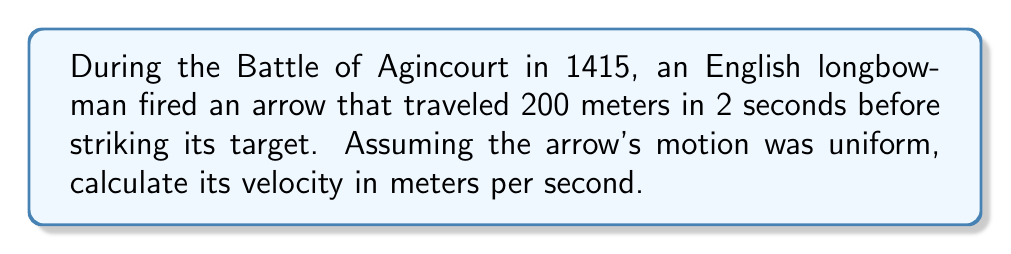Could you help me with this problem? To solve this problem, we'll use the concept of average velocity, which is defined as the displacement divided by the time taken. In this case, we have:

1. Distance traveled (displacement): $d = 200$ meters
2. Time taken: $t = 2$ seconds

The formula for average velocity is:

$$v = \frac{d}{t}$$

Where:
$v$ = velocity
$d$ = displacement (distance traveled)
$t$ = time taken

Substituting our known values:

$$v = \frac{200 \text{ m}}{2 \text{ s}}$$

Simplifying:

$$v = 100 \text{ m/s}$$

Therefore, the velocity of the arrow was 100 meters per second.
Answer: $100 \text{ m/s}$ 